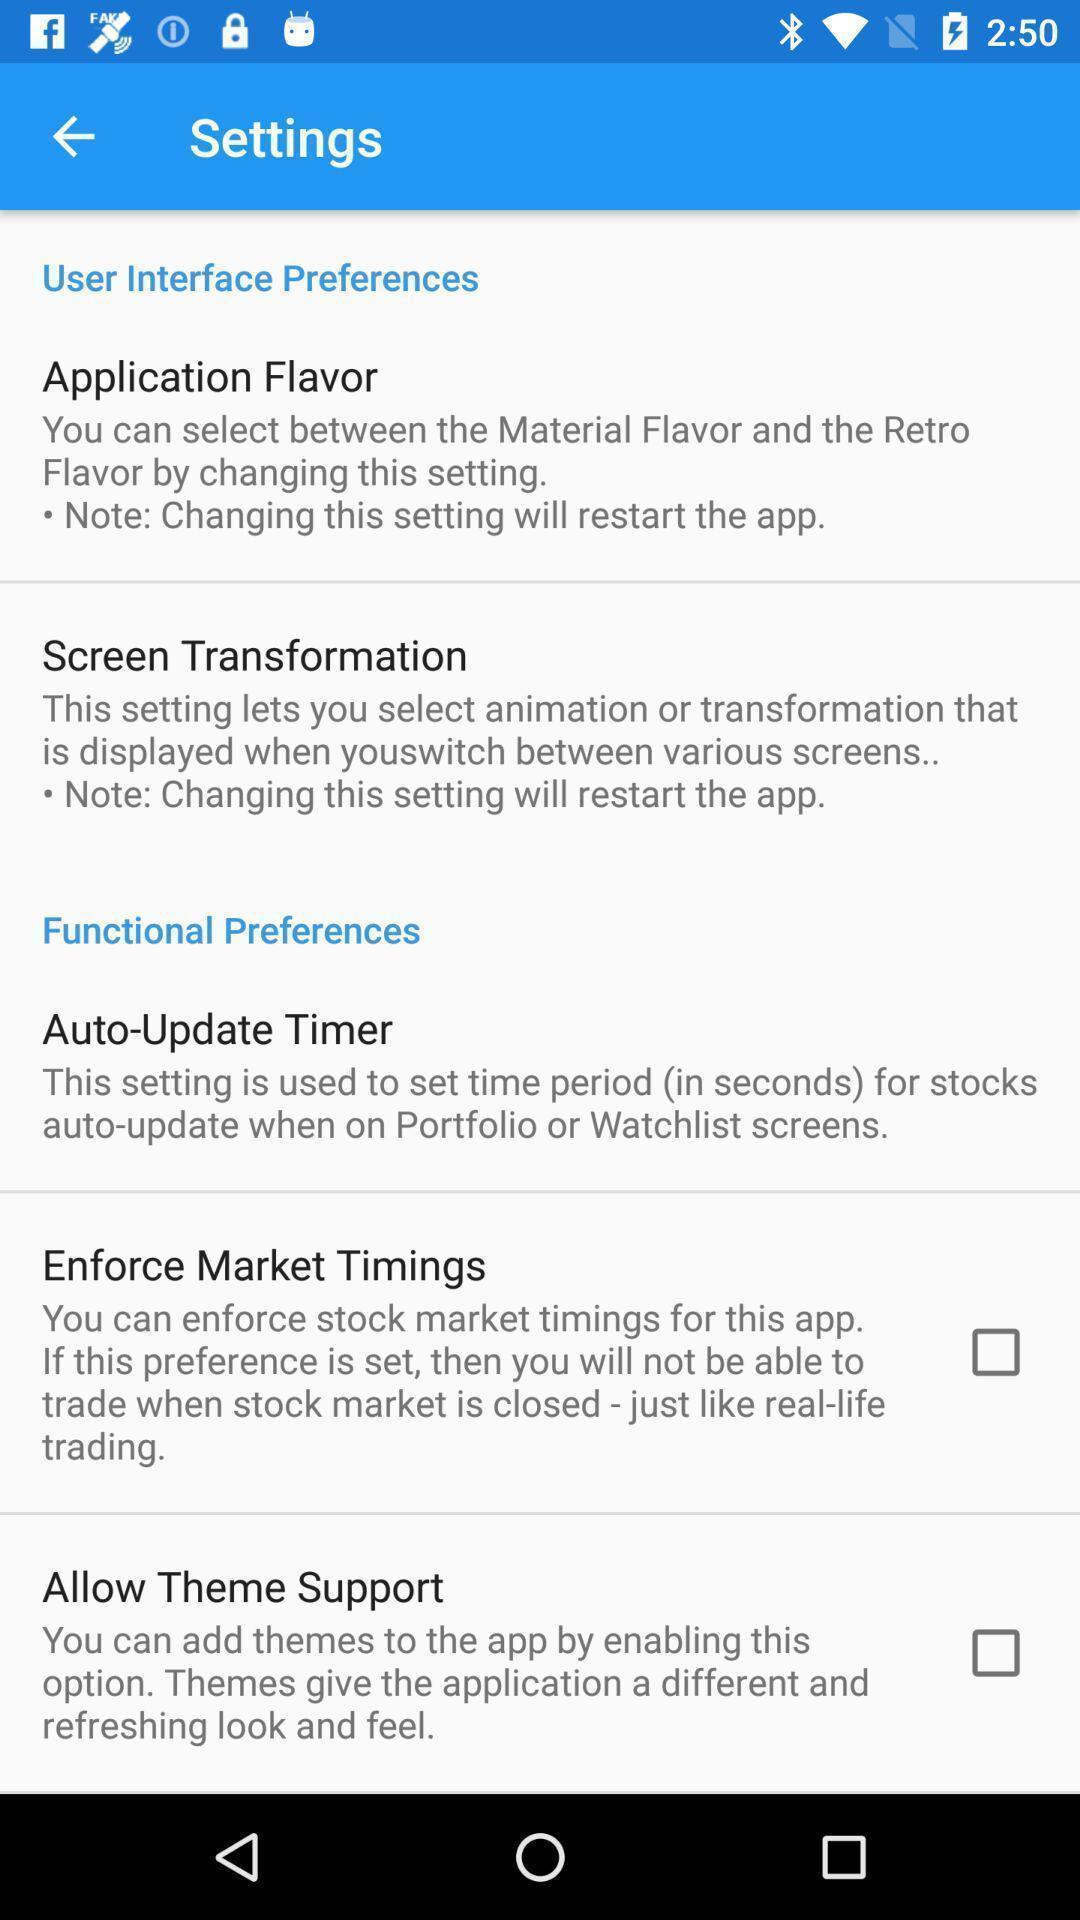Provide a description of this screenshot. Settings page with different options in the marketing app. 